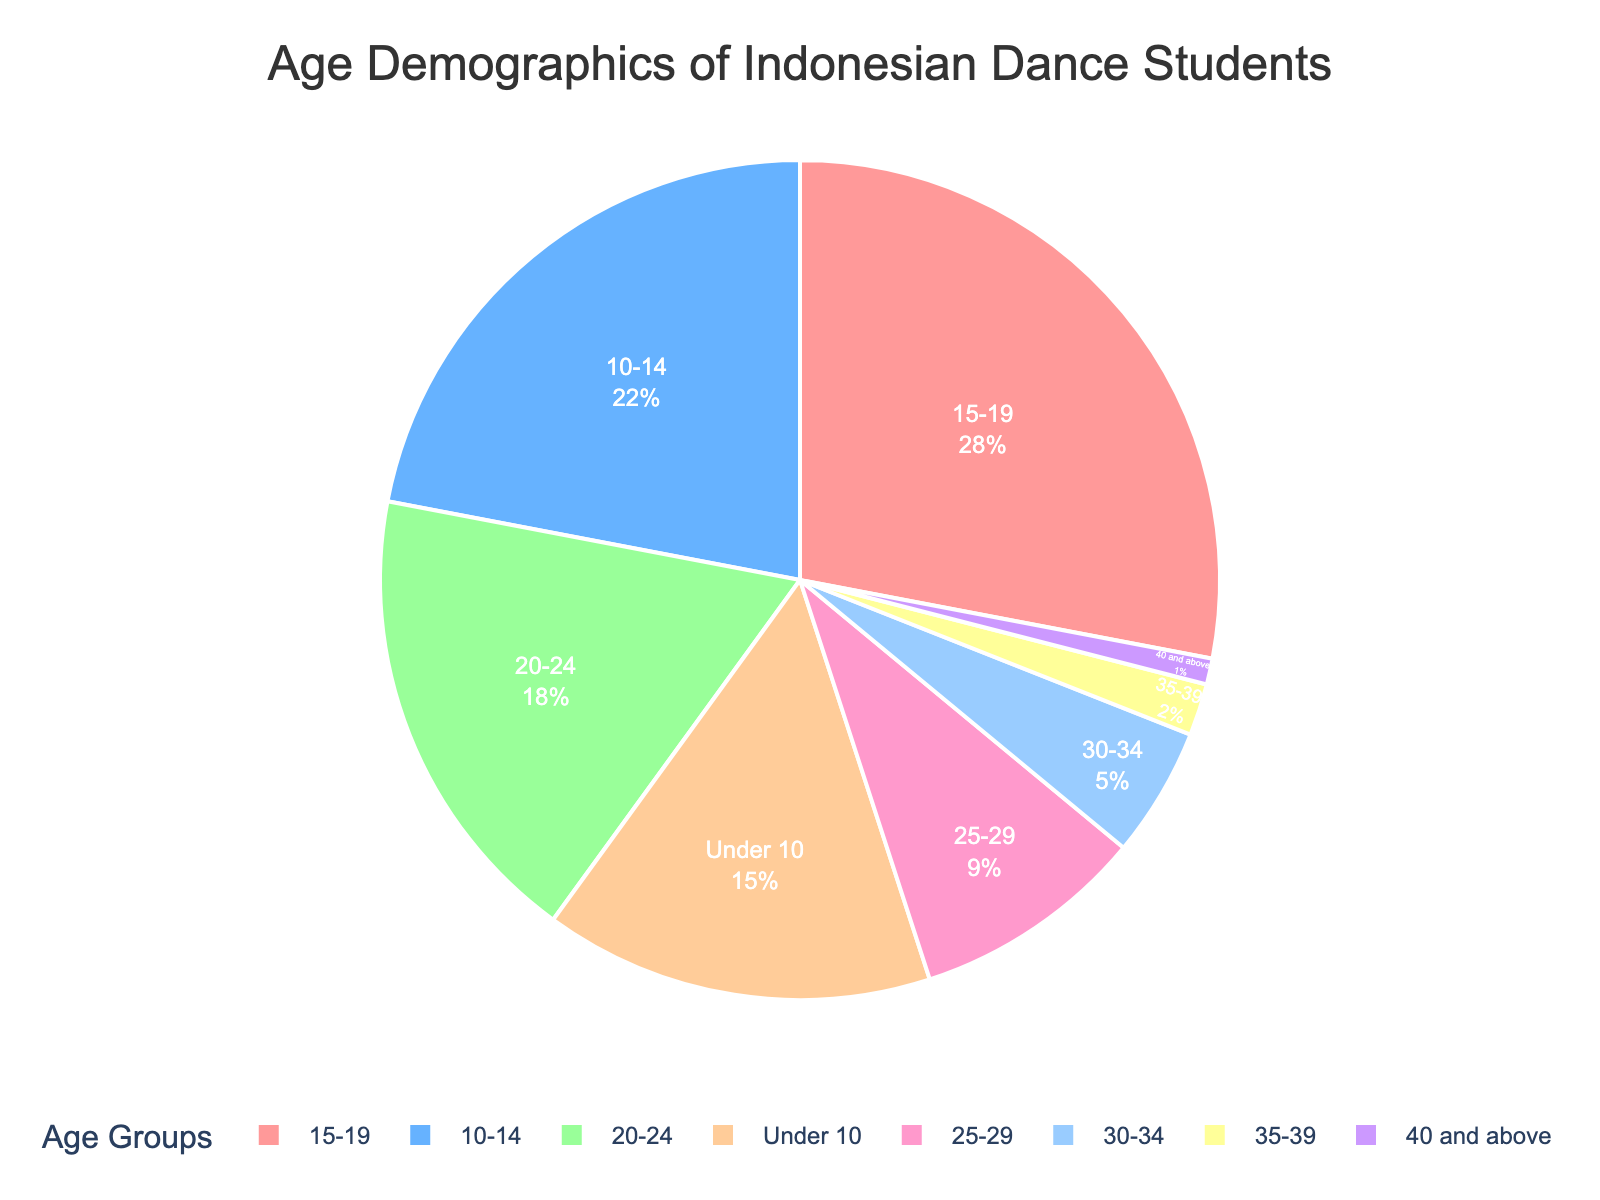Which age group has the highest percentage of dance students? The figure shows different age groups with their corresponding percentages. By observing the pie chart, one can identify the age group with the largest segment.
Answer: 15-19 What is the combined percentage of dance students who are under 10 years old and those who are between 20-24 years old? To find the combined percentage, add the values of the age groups "Under 10" (15%) and "20-24" (18%).
Answer: 33% Is the percentage of dance students aged 10-14 greater than those aged 25-29? Compare the segment sizes of the age groups "10-14" (22%) and "25-29" (9%).
Answer: Yes What is the difference in percentage between the age groups 15-19 and 30-34? Subtract the percentage of the age group "30-34" (5%) from the age group "15-19" (28%).
Answer: 23% Which color represents the age group 35-39? By visually observing the pie chart, identify the color associated with the segment labeled "35-39".
Answer: Purple What is the sum of the percentages of the age groups 25-29, 30-34, and 35-39? Add the percentages of the age groups "25-29" (9%), "30-34" (5%), and "35-39" (2%).
Answer: 16% Are there more dance students aged 40 and above or aged 35-39? Compare the percentages of the age groups "40 and above" (1%) and "35-39" (2%).
Answer: 35-39 What is the average percentage of dance students across all age groups? Add the percentages of all age groups and divide by the number of age groups (8). The total sum of percentages is 100%.
Answer: 12.5% Which age group has the smallest percentage of dance students, and what color represents it? Identify the age group with the smallest segment in the pie chart and note its color.
Answer: 40 and above, light purple 